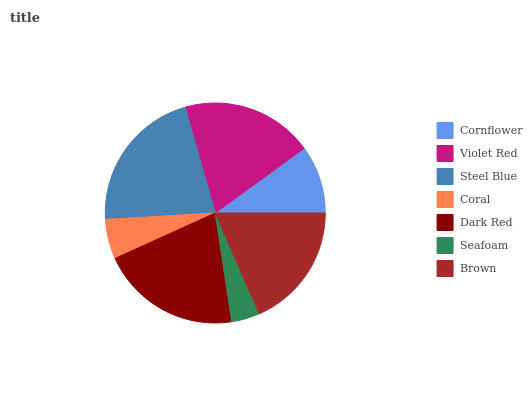Is Seafoam the minimum?
Answer yes or no. Yes. Is Steel Blue the maximum?
Answer yes or no. Yes. Is Violet Red the minimum?
Answer yes or no. No. Is Violet Red the maximum?
Answer yes or no. No. Is Violet Red greater than Cornflower?
Answer yes or no. Yes. Is Cornflower less than Violet Red?
Answer yes or no. Yes. Is Cornflower greater than Violet Red?
Answer yes or no. No. Is Violet Red less than Cornflower?
Answer yes or no. No. Is Brown the high median?
Answer yes or no. Yes. Is Brown the low median?
Answer yes or no. Yes. Is Dark Red the high median?
Answer yes or no. No. Is Coral the low median?
Answer yes or no. No. 